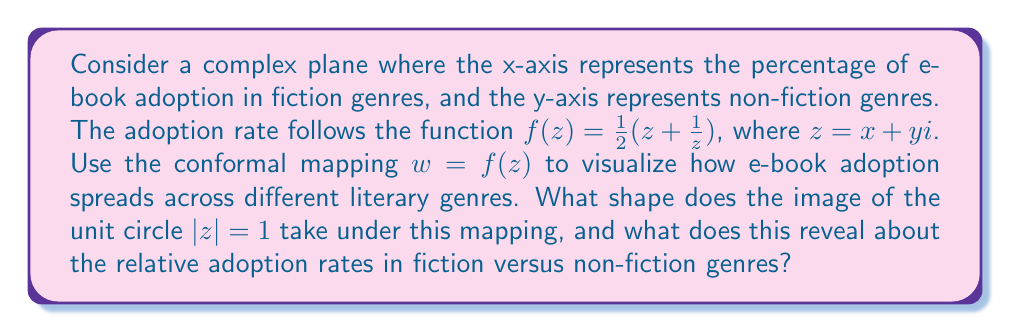Can you answer this question? To solve this problem, we'll follow these steps:

1) First, let's recall that the given function $f(z) = \frac{1}{2}(z + \frac{1}{z})$ is known as the Joukowski transformation.

2) The unit circle in the z-plane is defined by $z = e^{i\theta}$, where $0 \leq \theta < 2\pi$.

3) Let's apply the transformation to the unit circle:

   $$w = f(e^{i\theta}) = \frac{1}{2}(e^{i\theta} + e^{-i\theta})$$

4) Using Euler's formula, we can simplify this:

   $$w = \frac{1}{2}(\cos\theta + i\sin\theta + \cos\theta - i\sin\theta) = \cos\theta$$

5) This is the parametric form of a line segment on the real axis from -1 to 1.

6) In the context of our problem, this means that genres with equal adoption rates in fiction and non-fiction (represented by points on the unit circle) are mapped to a line segment on the real axis.

7) Points inside the unit circle (where fiction adoption > non-fiction adoption) are mapped to the upper half-plane, while points outside (where non-fiction adoption > fiction adoption) are mapped to the lower half-plane.

8) The Joukowski transformation maps the interior of the unit circle conformally onto the entire plane minus the line segment [-1,1] on the real axis.

This visualization reveals that:
- Genres with balanced adoption rates between fiction and non-fiction are represented on the real axis between -1 and 1.
- Genres with higher fiction adoption are in the upper half-plane.
- Genres with higher non-fiction adoption are in the lower half-plane.
- The extremes of adoption (either all fiction or all non-fiction) are mapped to points far from the origin.
Answer: The image of the unit circle under the mapping $w = \frac{1}{2}(z + \frac{1}{z})$ is a line segment from -1 to 1 on the real axis. This reveals that genres with equal adoption rates in fiction and non-fiction are mapped to this line segment, while genres with unequal adoption rates are mapped to points off this line, with fiction-dominant genres in the upper half-plane and non-fiction-dominant genres in the lower half-plane. 